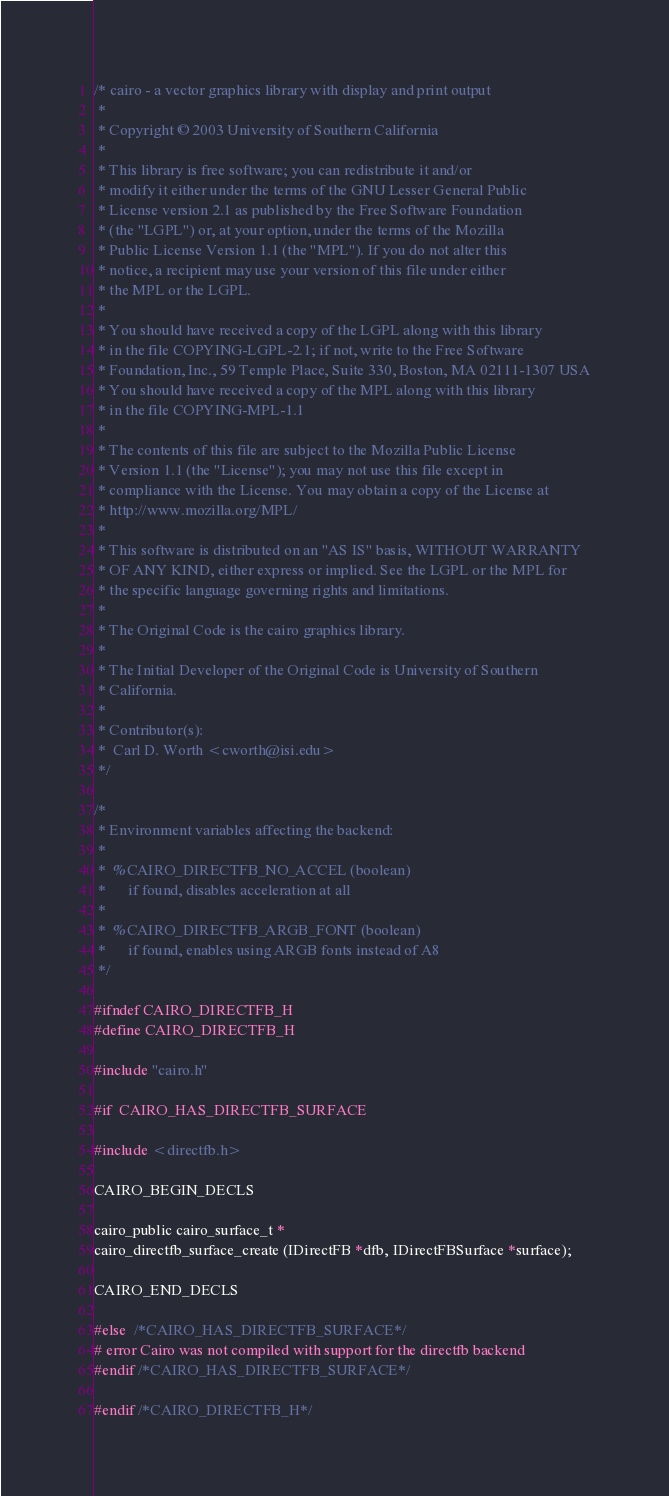Convert code to text. <code><loc_0><loc_0><loc_500><loc_500><_C_>/* cairo - a vector graphics library with display and print output
 *
 * Copyright © 2003 University of Southern California
 *
 * This library is free software; you can redistribute it and/or
 * modify it either under the terms of the GNU Lesser General Public
 * License version 2.1 as published by the Free Software Foundation
 * (the "LGPL") or, at your option, under the terms of the Mozilla
 * Public License Version 1.1 (the "MPL"). If you do not alter this
 * notice, a recipient may use your version of this file under either
 * the MPL or the LGPL.
 *
 * You should have received a copy of the LGPL along with this library
 * in the file COPYING-LGPL-2.1; if not, write to the Free Software
 * Foundation, Inc., 59 Temple Place, Suite 330, Boston, MA 02111-1307 USA
 * You should have received a copy of the MPL along with this library
 * in the file COPYING-MPL-1.1
 *
 * The contents of this file are subject to the Mozilla Public License
 * Version 1.1 (the "License"); you may not use this file except in
 * compliance with the License. You may obtain a copy of the License at
 * http://www.mozilla.org/MPL/
 *
 * This software is distributed on an "AS IS" basis, WITHOUT WARRANTY
 * OF ANY KIND, either express or implied. See the LGPL or the MPL for
 * the specific language governing rights and limitations.
 *
 * The Original Code is the cairo graphics library.
 *
 * The Initial Developer of the Original Code is University of Southern
 * California.
 *
 * Contributor(s):
 *	Carl D. Worth <cworth@isi.edu>
 */

/*
 * Environment variables affecting the backend:
 *
 *  %CAIRO_DIRECTFB_NO_ACCEL (boolean)
 *      if found, disables acceleration at all
 *
 *  %CAIRO_DIRECTFB_ARGB_FONT (boolean)
 *      if found, enables using ARGB fonts instead of A8
 */

#ifndef CAIRO_DIRECTFB_H
#define CAIRO_DIRECTFB_H

#include "cairo.h"

#if  CAIRO_HAS_DIRECTFB_SURFACE

#include <directfb.h>

CAIRO_BEGIN_DECLS

cairo_public cairo_surface_t *
cairo_directfb_surface_create (IDirectFB *dfb, IDirectFBSurface *surface);

CAIRO_END_DECLS

#else  /*CAIRO_HAS_DIRECTFB_SURFACE*/
# error Cairo was not compiled with support for the directfb backend
#endif /*CAIRO_HAS_DIRECTFB_SURFACE*/

#endif /*CAIRO_DIRECTFB_H*/
</code> 